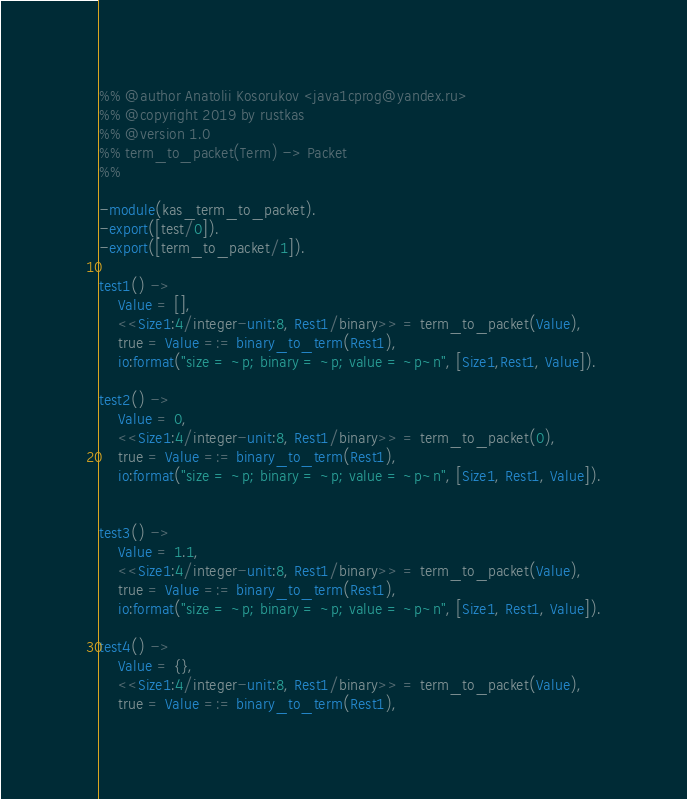<code> <loc_0><loc_0><loc_500><loc_500><_Erlang_>%% @author Anatolii Kosorukov <java1cprog@yandex.ru>
%% @copyright 2019 by rustkas
%% @version 1.0
%% term_to_packet(Term) -> Packet
%%

-module(kas_term_to_packet).
-export([test/0]).
-export([term_to_packet/1]).

test1() ->
	Value = [],
	<<Size1:4/integer-unit:8, Rest1/binary>> = term_to_packet(Value),
	true = Value =:= binary_to_term(Rest1),
	io:format("size = ~p; binary = ~p; value = ~p~n", [Size1,Rest1, Value]).

test2() ->
	Value = 0,
	<<Size1:4/integer-unit:8, Rest1/binary>> = term_to_packet(0),
	true = Value =:= binary_to_term(Rest1),
	io:format("size = ~p; binary = ~p; value = ~p~n", [Size1, Rest1, Value]).


test3() ->
	Value = 1.1,
	<<Size1:4/integer-unit:8, Rest1/binary>> = term_to_packet(Value),
	true = Value =:= binary_to_term(Rest1), 
	io:format("size = ~p; binary = ~p; value = ~p~n", [Size1, Rest1, Value]).

test4() ->
	Value = {},
	<<Size1:4/integer-unit:8, Rest1/binary>> = term_to_packet(Value),
	true = Value =:= binary_to_term(Rest1),</code> 